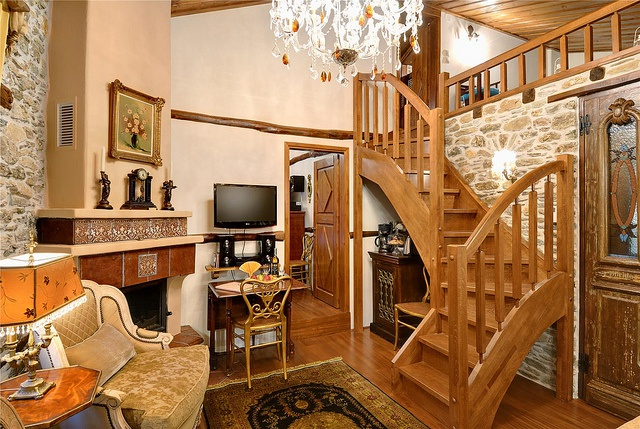Describe the objects in this image and their specific colors. I can see couch in olive and tan tones, chair in olive and tan tones, chair in olive, maroon, and black tones, tv in olive, black, and gray tones, and chair in olive, brown, black, maroon, and orange tones in this image. 